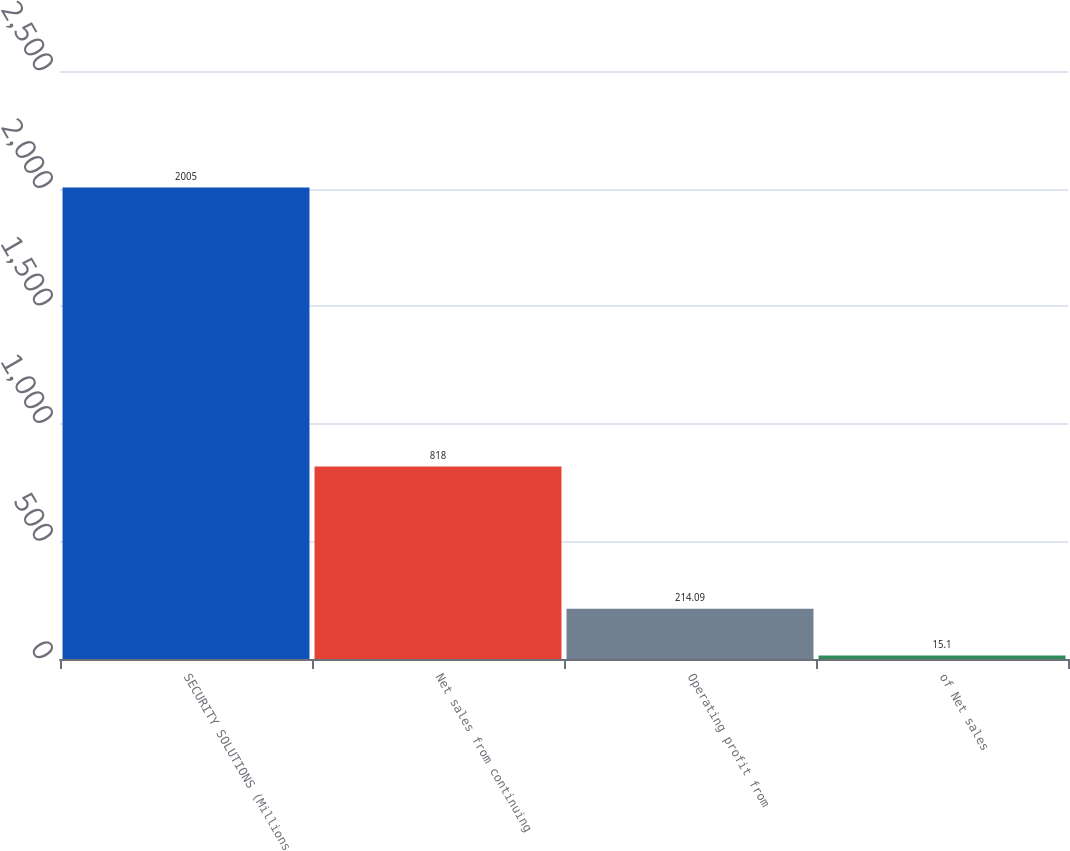Convert chart to OTSL. <chart><loc_0><loc_0><loc_500><loc_500><bar_chart><fcel>SECURITY SOLUTIONS (Millions<fcel>Net sales from continuing<fcel>Operating profit from<fcel>of Net sales<nl><fcel>2005<fcel>818<fcel>214.09<fcel>15.1<nl></chart> 